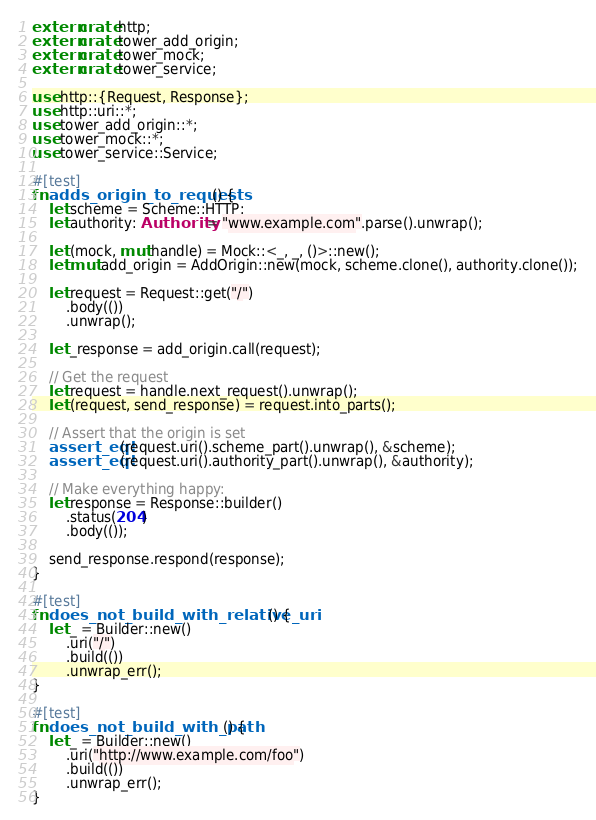Convert code to text. <code><loc_0><loc_0><loc_500><loc_500><_Rust_>extern crate http;
extern crate tower_add_origin;
extern crate tower_mock;
extern crate tower_service;

use http::{Request, Response};
use http::uri::*;
use tower_add_origin::*;
use tower_mock::*;
use tower_service::Service;

#[test]
fn adds_origin_to_requests() {
    let scheme = Scheme::HTTP;
    let authority: Authority = "www.example.com".parse().unwrap();

    let (mock, mut handle) = Mock::<_, _, ()>::new();
    let mut add_origin = AddOrigin::new(mock, scheme.clone(), authority.clone());

    let request = Request::get("/")
        .body(())
        .unwrap();

    let _response = add_origin.call(request);

    // Get the request
    let request = handle.next_request().unwrap();
    let (request, send_response) = request.into_parts();

    // Assert that the origin is set
    assert_eq!(request.uri().scheme_part().unwrap(), &scheme);
    assert_eq!(request.uri().authority_part().unwrap(), &authority);

    // Make everything happy:
    let response = Response::builder()
        .status(204)
        .body(());

    send_response.respond(response);
}

#[test]
fn does_not_build_with_relative_uri() {
    let _ = Builder::new()
        .uri("/")
        .build(())
        .unwrap_err();
}

#[test]
fn does_not_build_with_path() {
    let _ = Builder::new()
        .uri("http://www.example.com/foo")
        .build(())
        .unwrap_err();
}
</code> 